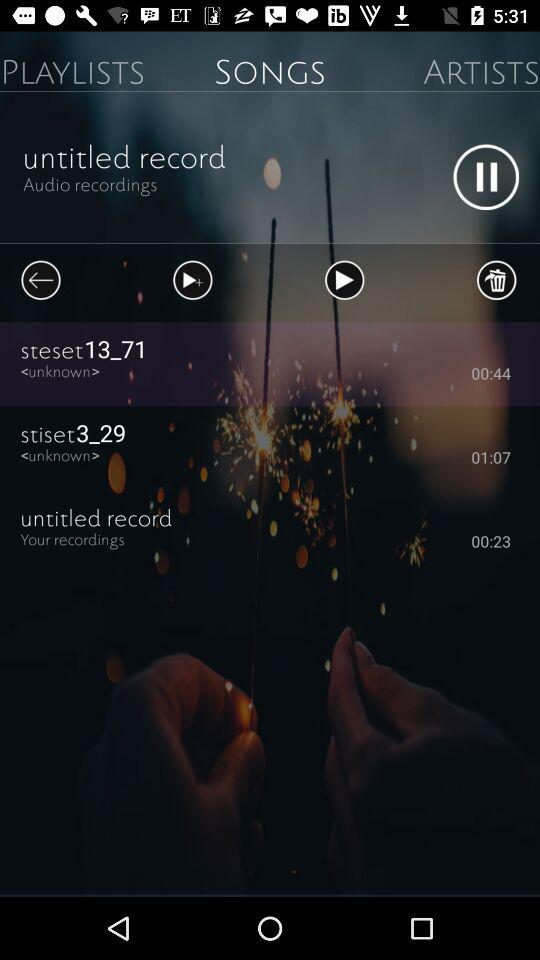What is the duration of the "untitled record"? The duration of the "untitled record" is 23 seconds. 